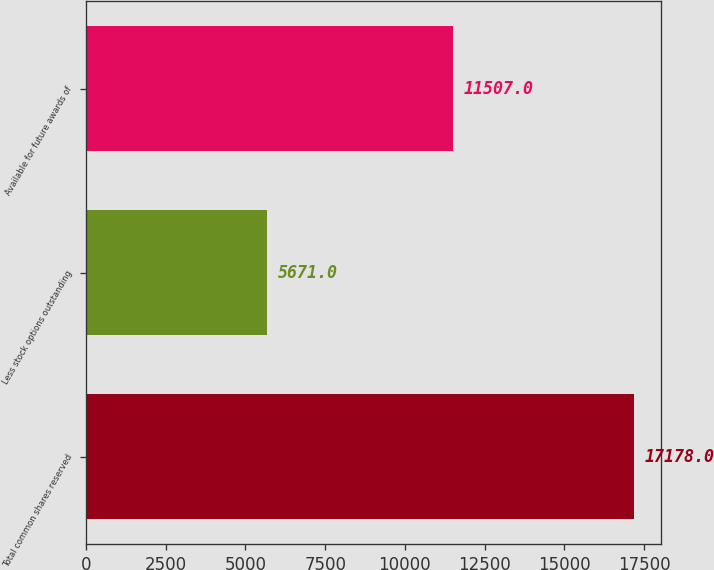<chart> <loc_0><loc_0><loc_500><loc_500><bar_chart><fcel>Total common shares reserved<fcel>Less stock options outstanding<fcel>Available for future awards of<nl><fcel>17178<fcel>5671<fcel>11507<nl></chart> 